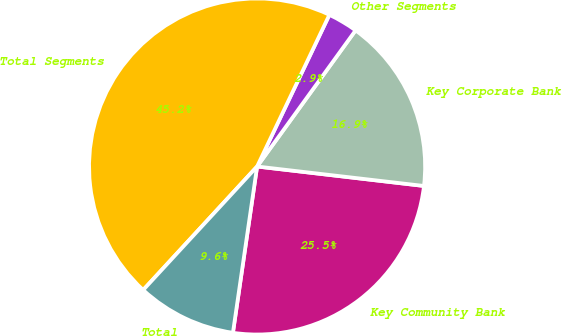Convert chart. <chart><loc_0><loc_0><loc_500><loc_500><pie_chart><fcel>Key Community Bank<fcel>Key Corporate Bank<fcel>Other Segments<fcel>Total Segments<fcel>Total<nl><fcel>25.45%<fcel>16.88%<fcel>2.89%<fcel>45.22%<fcel>9.56%<nl></chart> 